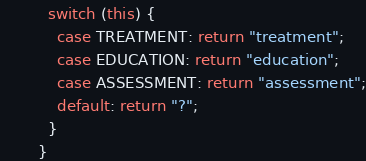<code> <loc_0><loc_0><loc_500><loc_500><_Java_>          switch (this) {
            case TREATMENT: return "treatment";
            case EDUCATION: return "education";
            case ASSESSMENT: return "assessment";
            default: return "?";
          }
        }</code> 